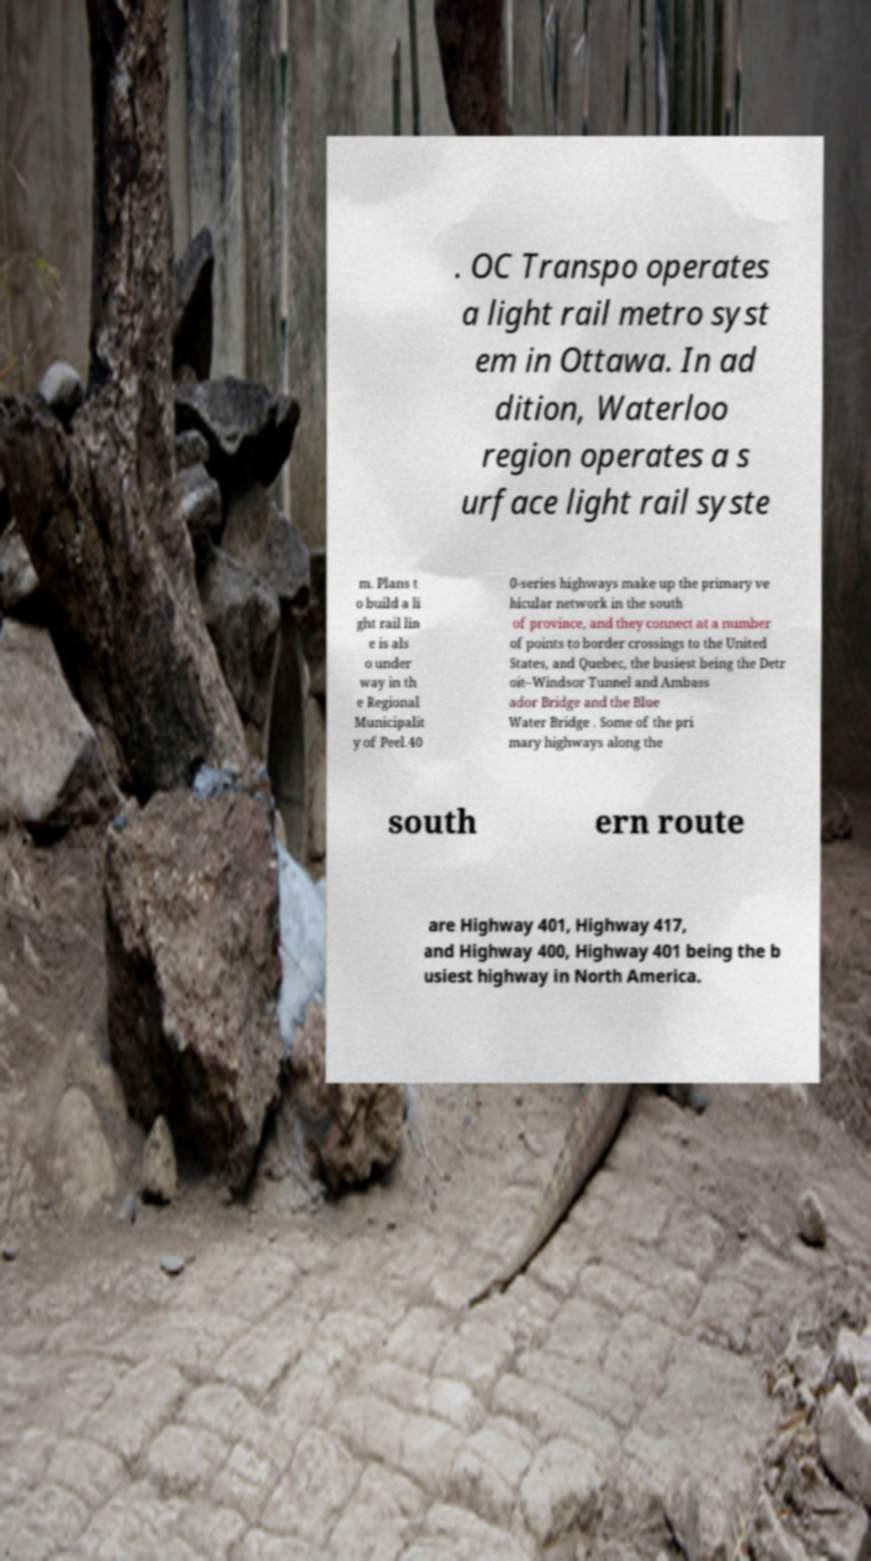I need the written content from this picture converted into text. Can you do that? . OC Transpo operates a light rail metro syst em in Ottawa. In ad dition, Waterloo region operates a s urface light rail syste m. Plans t o build a li ght rail lin e is als o under way in th e Regional Municipalit y of Peel.40 0-series highways make up the primary ve hicular network in the south of province, and they connect at a number of points to border crossings to the United States, and Quebec, the busiest being the Detr oit–Windsor Tunnel and Ambass ador Bridge and the Blue Water Bridge . Some of the pri mary highways along the south ern route are Highway 401, Highway 417, and Highway 400, Highway 401 being the b usiest highway in North America. 